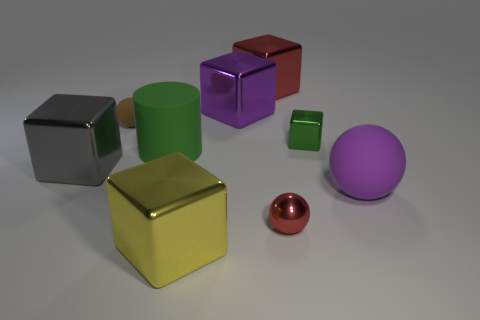Subtract 2 blocks. How many blocks are left? 3 Subtract all yellow blocks. How many blocks are left? 4 Subtract all large gray cubes. How many cubes are left? 4 Subtract all cyan cubes. Subtract all cyan cylinders. How many cubes are left? 5 Add 1 green cylinders. How many objects exist? 10 Subtract all cubes. How many objects are left? 4 Subtract all gray cubes. Subtract all big red rubber balls. How many objects are left? 8 Add 1 yellow metallic cubes. How many yellow metallic cubes are left? 2 Add 6 yellow metal objects. How many yellow metal objects exist? 7 Subtract 1 purple balls. How many objects are left? 8 